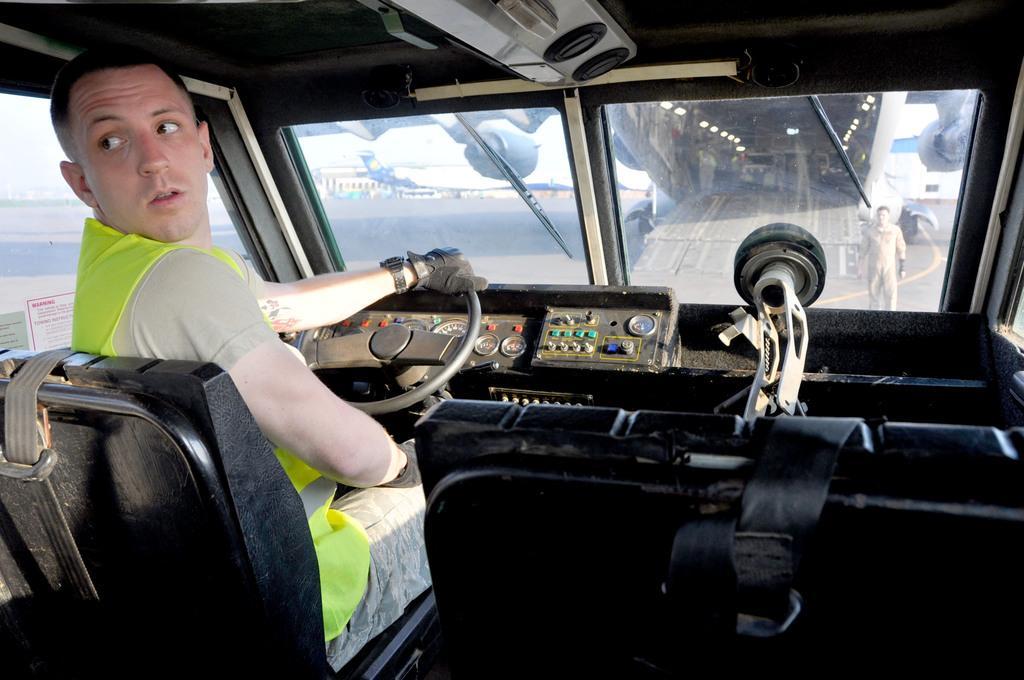Describe this image in one or two sentences. The image is taken from inside a vehicle,a man is sitting in front of the steering and outside the vehicle there are two planes and beside one of the plane there is a person standing on the ground. 